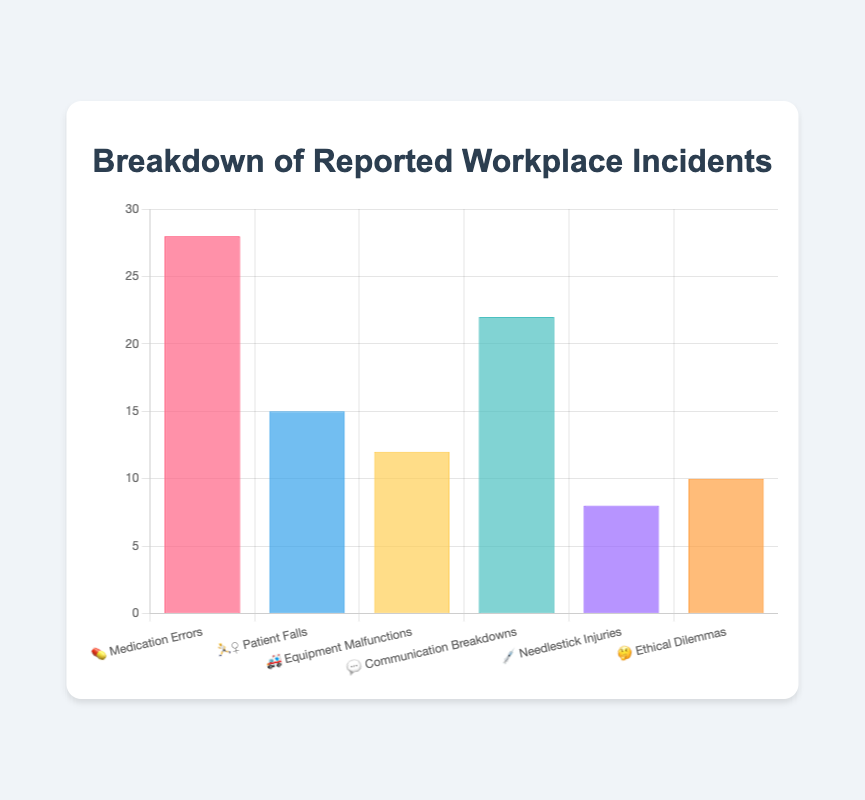How many total incidents were reported? Add up all the counts from each incident type: 28 (Medication Errors) + 15 (Patient Falls) + 12 (Equipment Malfunctions) + 22 (Communication Breakdowns) + 8 (Needlestick Injuries) + 10 (Ethical Dilemmas) = 95
Answer: 95 Which type of incident has the highest count? Identify the highest value among the counts: Medication Errors (28), Patient Falls (15), Equipment Malfunctions (12), Communication Breakdowns (22), Needlestick Injuries (8), Ethical Dilemmas (10). The highest count is 28 for Medication Errors
Answer: Medication Errors What is the count difference between Medication Errors and Needlestick Injuries? Subtract the count for Needlestick Injuries from the count for Medication Errors: 28 (Medication Errors) - 8 (Needlestick Injuries) = 20
Answer: 20 Are there more Communication Breakdowns or Patient Falls? Compare the counts: Communication Breakdowns (22) and Patient Falls (15). 22 is greater than 15
Answer: Communication Breakdowns What is the average number of incidents reported per type? Calculate the average by dividing the total number of incidents by the number of incident types: 95 incidents / 6 types = 15.83 (rounded to two decimal places)
Answer: 15.83 Which incident type has the fewest reports? Identify the lowest count among the incidents: Medication Errors (28), Patient Falls (15), Equipment Malfunctions (12), Communication Breakdowns (22), Needlestick Injuries (8), Ethical Dilemmas (10). The lowest count is 8 for Needlestick Injuries
Answer: Needlestick Injuries How many incidents are related to Equipment Malfunctions and Ethical Dilemmas combined? Add the counts of both types: 12 (Equipment Malfunctions) + 10 (Ethical Dilemmas) = 22
Answer: 22 What percentage of the reported incidents are Medication Errors? Divide the count of Medication Errors by the total number of incidents and multiply by 100 to get the percentage: (28 / 95) * 100 = 29.47% (rounded to two decimal places)
Answer: 29.47% By how much do Communication Breakdowns outnumber Ethical Dilemmas? Subtract the count for Ethical Dilemmas from the count for Communication Breakdowns: 22 (Communication Breakdowns) - 10 (Ethical Dilemmas) = 12
Answer: 12 What's the sum of Patient Falls, Equipment Malfunctions, and Needlestick Injuries? Add the counts for these incidents: 15 (Patient Falls) + 12 (Equipment Malfunctions) + 8 (Needlestick Injuries) = 35
Answer: 35 